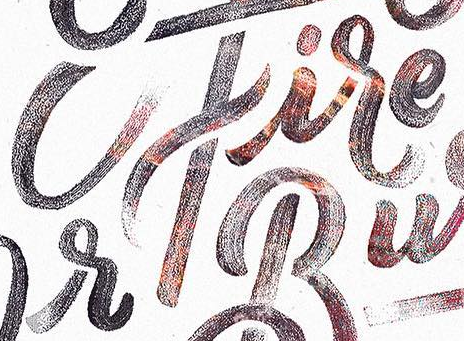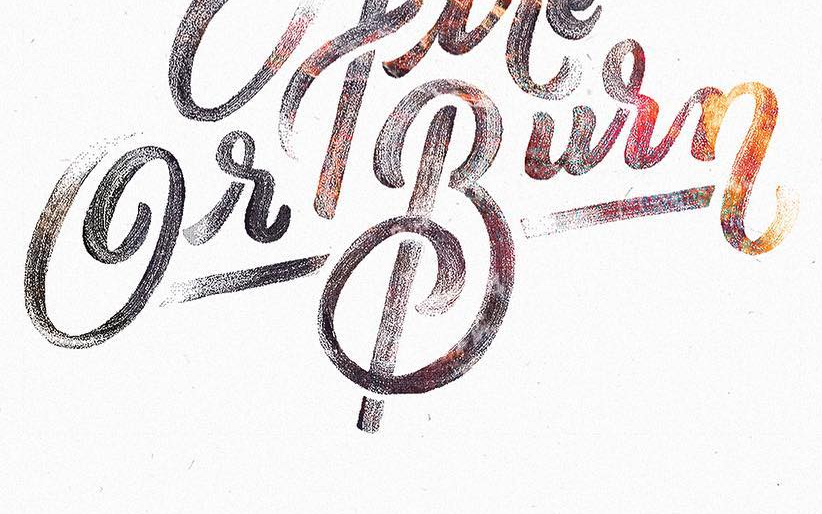What text is displayed in these images sequentially, separated by a semicolon? cfire; GrBurn 